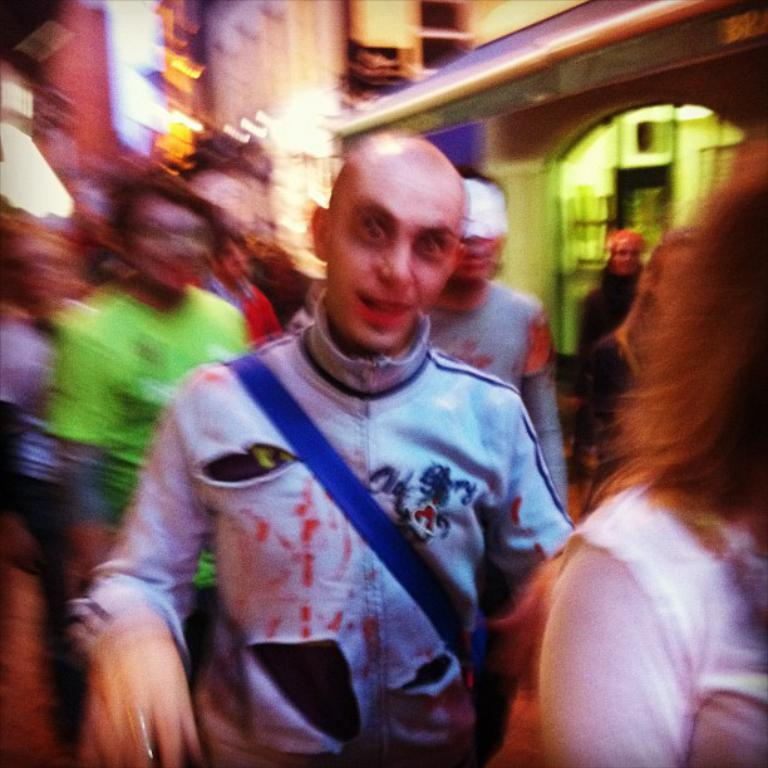What can be seen in the image? There are people standing in the image. What is visible in the background of the image? There are buildings in the background of the image. Can you describe the quality of the image? The image is slightly blurry. What type of glue is being used to hold the basket together in the image? There is no basket or glue present in the image. What type of hospital can be seen in the background of the image? There is no hospital visible in the image; only buildings are present in the background. 